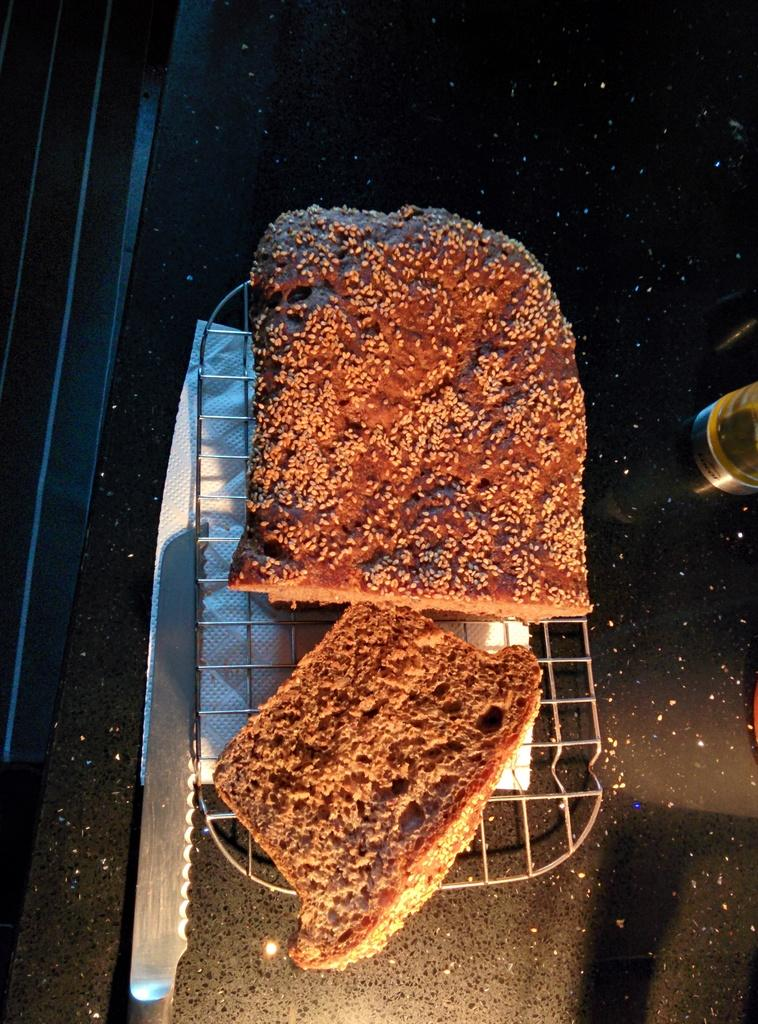What piece of furniture is present in the image? There is a table in the image. What type of food item can be seen on the table? There is bread on the table. What item is available for wiping or cleaning purposes? There is a napkin on the table. What utensil is present on the table? There is a knife on the table. What is the purpose of the tray on the table? The tray on the table is likely used for holding or serving items. Can you describe the unspecified object on the table? Unfortunately, the facts provided do not specify the nature of the unspecified object on the table. What type of truck can be seen in the image? There is no truck present in the image. 